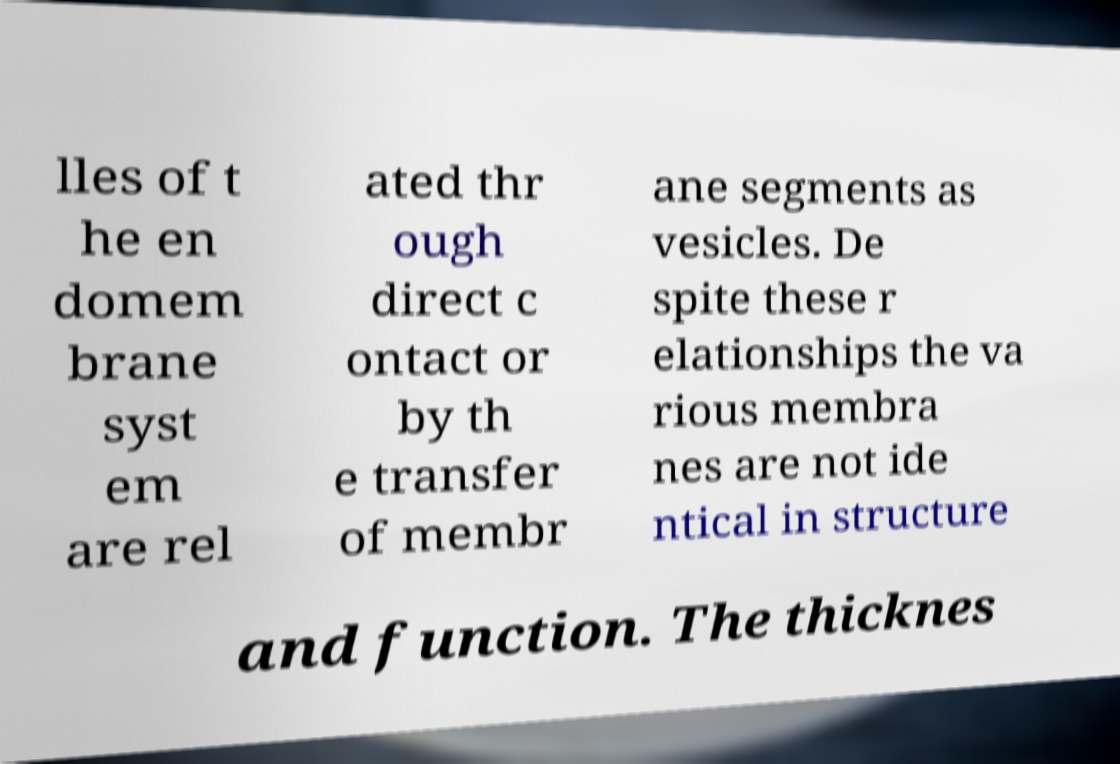Can you accurately transcribe the text from the provided image for me? lles of t he en domem brane syst em are rel ated thr ough direct c ontact or by th e transfer of membr ane segments as vesicles. De spite these r elationships the va rious membra nes are not ide ntical in structure and function. The thicknes 